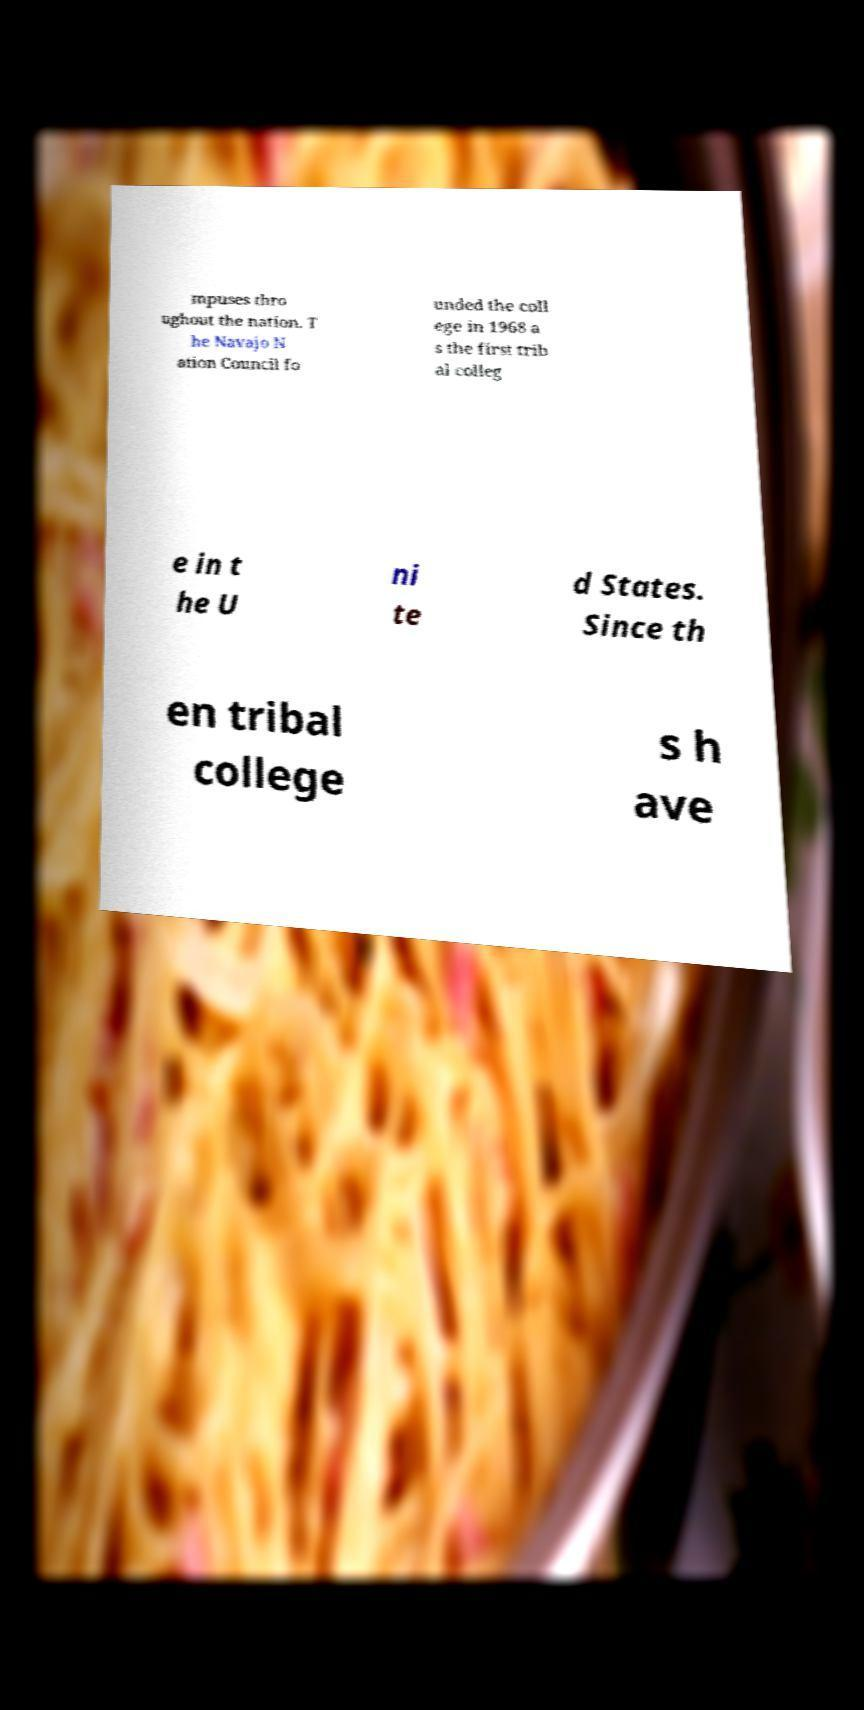For documentation purposes, I need the text within this image transcribed. Could you provide that? mpuses thro ughout the nation. T he Navajo N ation Council fo unded the coll ege in 1968 a s the first trib al colleg e in t he U ni te d States. Since th en tribal college s h ave 